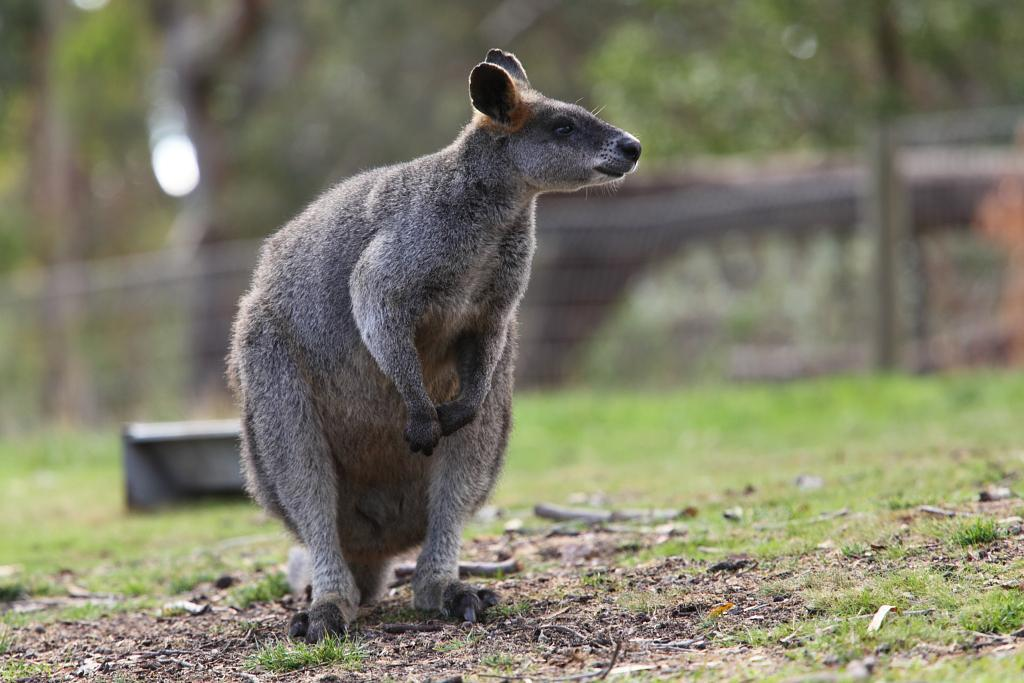What animal is in the foreground of the image? There is a kangaroo in the foreground of the image. What is the kangaroo's position in the image? The kangaroo is on the ground. Can you describe the background of the image? The background of the image is blurred. What type of twig is the kangaroo holding in its pouch in the image? There is no twig present in the image, and the kangaroo is not holding anything in its pouch. What type of ship can be seen sailing in the background of the image? There is no ship visible in the image, as the background is blurred. 